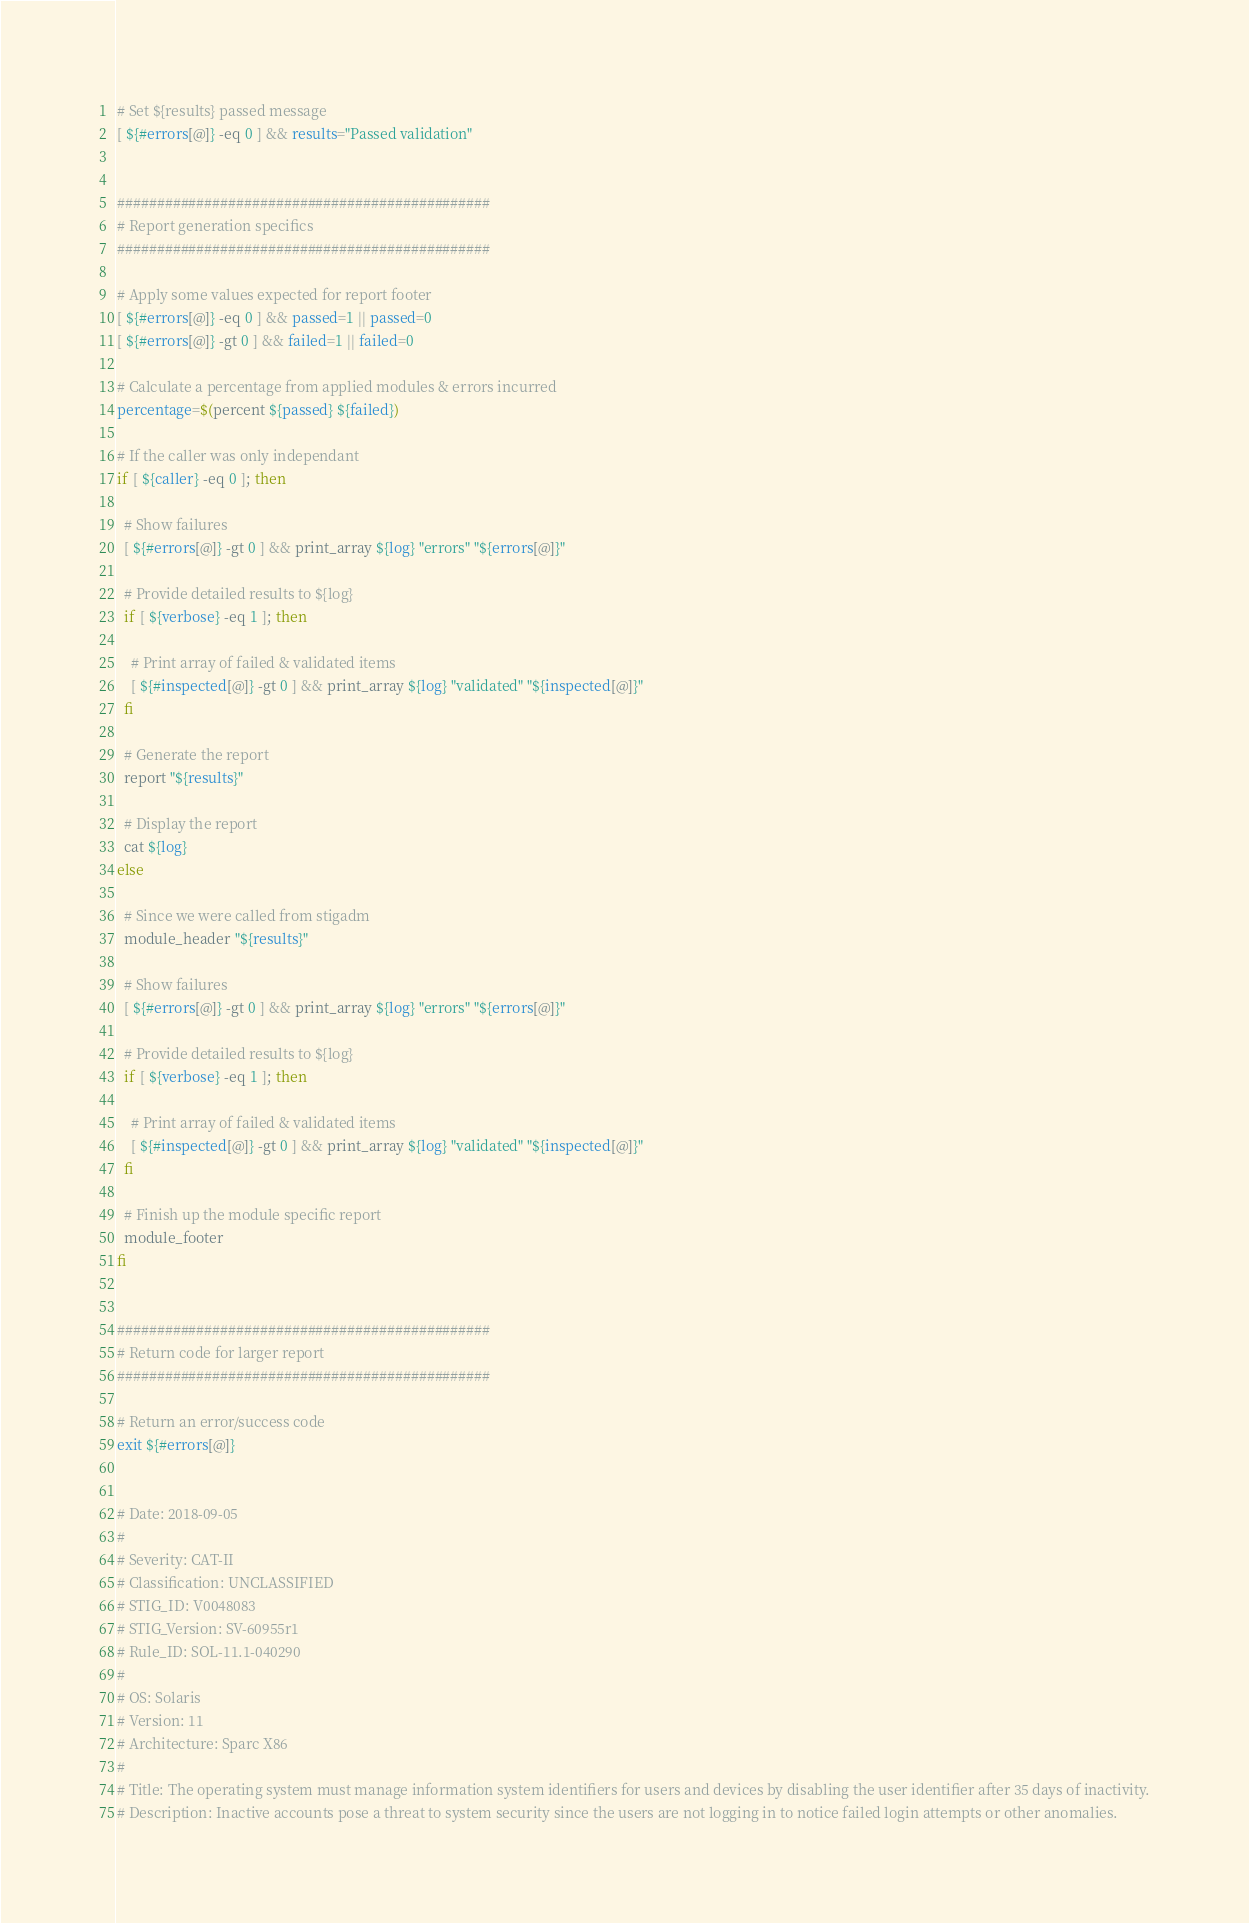<code> <loc_0><loc_0><loc_500><loc_500><_Bash_># Set ${results} passed message
[ ${#errors[@]} -eq 0 ] && results="Passed validation"


###############################################
# Report generation specifics
###############################################

# Apply some values expected for report footer
[ ${#errors[@]} -eq 0 ] && passed=1 || passed=0
[ ${#errors[@]} -gt 0 ] && failed=1 || failed=0

# Calculate a percentage from applied modules & errors incurred
percentage=$(percent ${passed} ${failed})

# If the caller was only independant
if [ ${caller} -eq 0 ]; then

  # Show failures
  [ ${#errors[@]} -gt 0 ] && print_array ${log} "errors" "${errors[@]}"

  # Provide detailed results to ${log}
  if [ ${verbose} -eq 1 ]; then

    # Print array of failed & validated items
    [ ${#inspected[@]} -gt 0 ] && print_array ${log} "validated" "${inspected[@]}"
  fi

  # Generate the report
  report "${results}"

  # Display the report
  cat ${log}
else

  # Since we were called from stigadm
  module_header "${results}"

  # Show failures
  [ ${#errors[@]} -gt 0 ] && print_array ${log} "errors" "${errors[@]}"

  # Provide detailed results to ${log}
  if [ ${verbose} -eq 1 ]; then

    # Print array of failed & validated items
    [ ${#inspected[@]} -gt 0 ] && print_array ${log} "validated" "${inspected[@]}"
  fi

  # Finish up the module specific report
  module_footer
fi


###############################################
# Return code for larger report
###############################################

# Return an error/success code
exit ${#errors[@]}


# Date: 2018-09-05
#
# Severity: CAT-II
# Classification: UNCLASSIFIED
# STIG_ID: V0048083
# STIG_Version: SV-60955r1
# Rule_ID: SOL-11.1-040290
#
# OS: Solaris
# Version: 11
# Architecture: Sparc X86
#
# Title: The operating system must manage information system identifiers for users and devices by disabling the user identifier after 35 days of inactivity.
# Description: Inactive accounts pose a threat to system security since the users are not logging in to notice failed login attempts or other anomalies.
</code> 